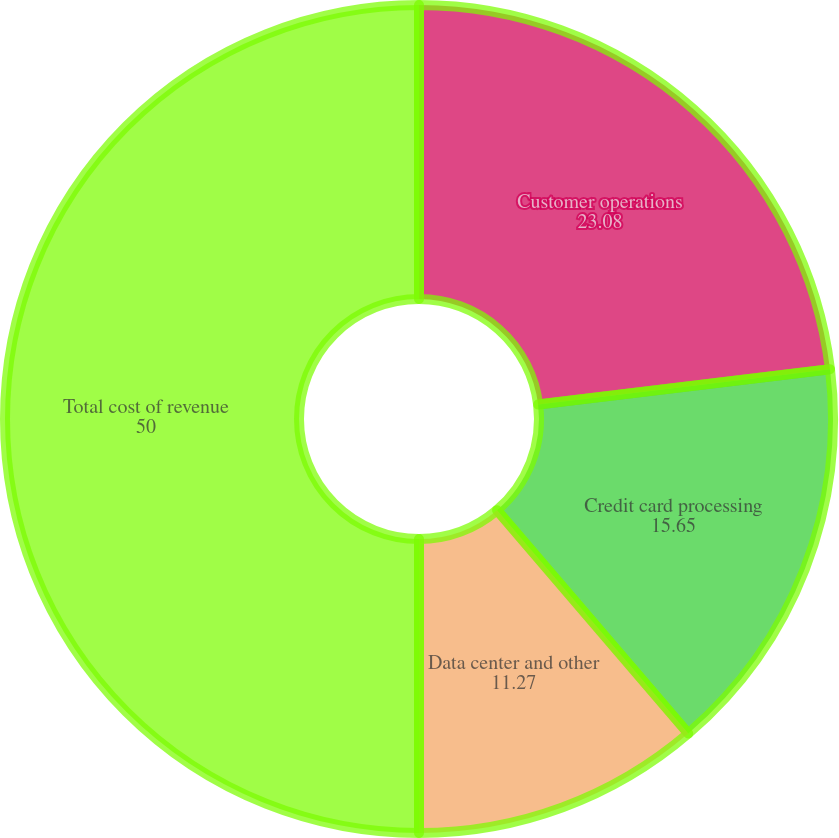<chart> <loc_0><loc_0><loc_500><loc_500><pie_chart><fcel>Customer operations<fcel>Credit card processing<fcel>Data center and other<fcel>Total cost of revenue<nl><fcel>23.08%<fcel>15.65%<fcel>11.27%<fcel>50.0%<nl></chart> 